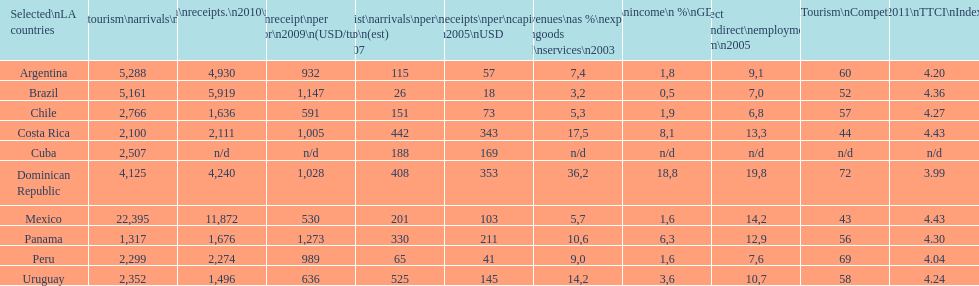Give me the full table as a dictionary. {'header': ['Selected\\nLA countries', 'Internl.\\ntourism\\narrivals\\n2010\\n(x 1000)', 'Internl.\\ntourism\\nreceipts.\\n2010\\n(USD\\n(x1000)', 'Avg\\nreceipt\\nper visitor\\n2009\\n(USD/turista)', 'Tourist\\narrivals\\nper\\n1000 inhab\\n(est) \\n2007', 'Receipts\\nper\\ncapita \\n2005\\nUSD', 'Revenues\\nas\xa0%\\nexports of\\ngoods and\\nservices\\n2003', 'Tourism\\nincome\\n\xa0%\\nGDP\\n2003', '% Direct and\\nindirect\\nemployment\\nin tourism\\n2005', 'World\\nranking\\nTourism\\nCompetitiv.\\nTTCI\\n2011', '2011\\nTTCI\\nIndex'], 'rows': [['Argentina', '5,288', '4,930', '932', '115', '57', '7,4', '1,8', '9,1', '60', '4.20'], ['Brazil', '5,161', '5,919', '1,147', '26', '18', '3,2', '0,5', '7,0', '52', '4.36'], ['Chile', '2,766', '1,636', '591', '151', '73', '5,3', '1,9', '6,8', '57', '4.27'], ['Costa Rica', '2,100', '2,111', '1,005', '442', '343', '17,5', '8,1', '13,3', '44', '4.43'], ['Cuba', '2,507', 'n/d', 'n/d', '188', '169', 'n/d', 'n/d', 'n/d', 'n/d', 'n/d'], ['Dominican Republic', '4,125', '4,240', '1,028', '408', '353', '36,2', '18,8', '19,8', '72', '3.99'], ['Mexico', '22,395', '11,872', '530', '201', '103', '5,7', '1,6', '14,2', '43', '4.43'], ['Panama', '1,317', '1,676', '1,273', '330', '211', '10,6', '6,3', '12,9', '56', '4.30'], ['Peru', '2,299', '2,274', '989', '65', '41', '9,0', '1,6', '7,6', '69', '4.04'], ['Uruguay', '2,352', '1,496', '636', '525', '145', '14,2', '3,6', '10,7', '58', '4.24']]} How does brazil rank in average receipts per visitor in 2009? 1,147. 